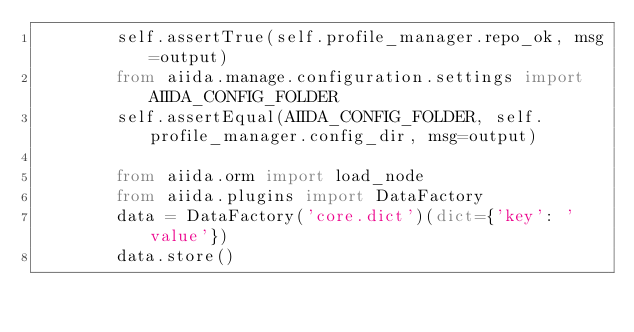<code> <loc_0><loc_0><loc_500><loc_500><_Python_>        self.assertTrue(self.profile_manager.repo_ok, msg=output)
        from aiida.manage.configuration.settings import AIIDA_CONFIG_FOLDER
        self.assertEqual(AIIDA_CONFIG_FOLDER, self.profile_manager.config_dir, msg=output)

        from aiida.orm import load_node
        from aiida.plugins import DataFactory
        data = DataFactory('core.dict')(dict={'key': 'value'})
        data.store()</code> 